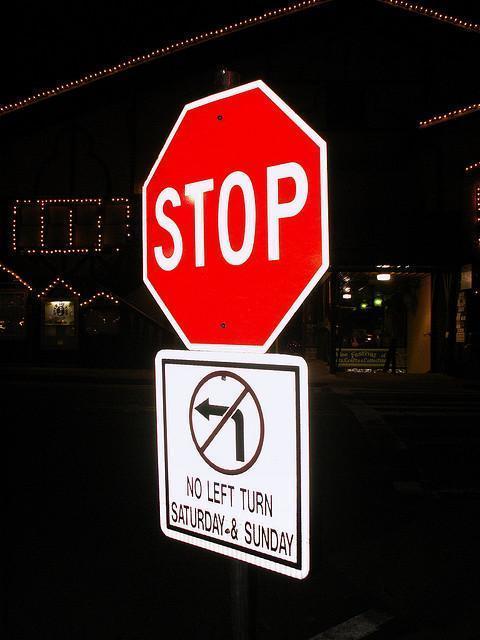How many people have remotes in their hands?
Give a very brief answer. 0. 